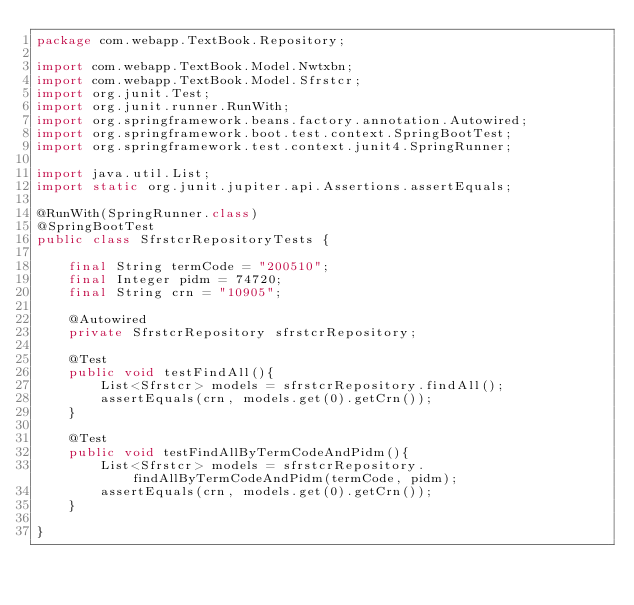<code> <loc_0><loc_0><loc_500><loc_500><_Java_>package com.webapp.TextBook.Repository;

import com.webapp.TextBook.Model.Nwtxbn;
import com.webapp.TextBook.Model.Sfrstcr;
import org.junit.Test;
import org.junit.runner.RunWith;
import org.springframework.beans.factory.annotation.Autowired;
import org.springframework.boot.test.context.SpringBootTest;
import org.springframework.test.context.junit4.SpringRunner;

import java.util.List;
import static org.junit.jupiter.api.Assertions.assertEquals;

@RunWith(SpringRunner.class)
@SpringBootTest
public class SfrstcrRepositoryTests {

    final String termCode = "200510";
    final Integer pidm = 74720;
    final String crn = "10905";

    @Autowired
    private SfrstcrRepository sfrstcrRepository;

    @Test
    public void testFindAll(){
        List<Sfrstcr> models = sfrstcrRepository.findAll();
        assertEquals(crn, models.get(0).getCrn());
    }

    @Test
    public void testFindAllByTermCodeAndPidm(){
        List<Sfrstcr> models = sfrstcrRepository.findAllByTermCodeAndPidm(termCode, pidm);
        assertEquals(crn, models.get(0).getCrn());
    }

}
</code> 